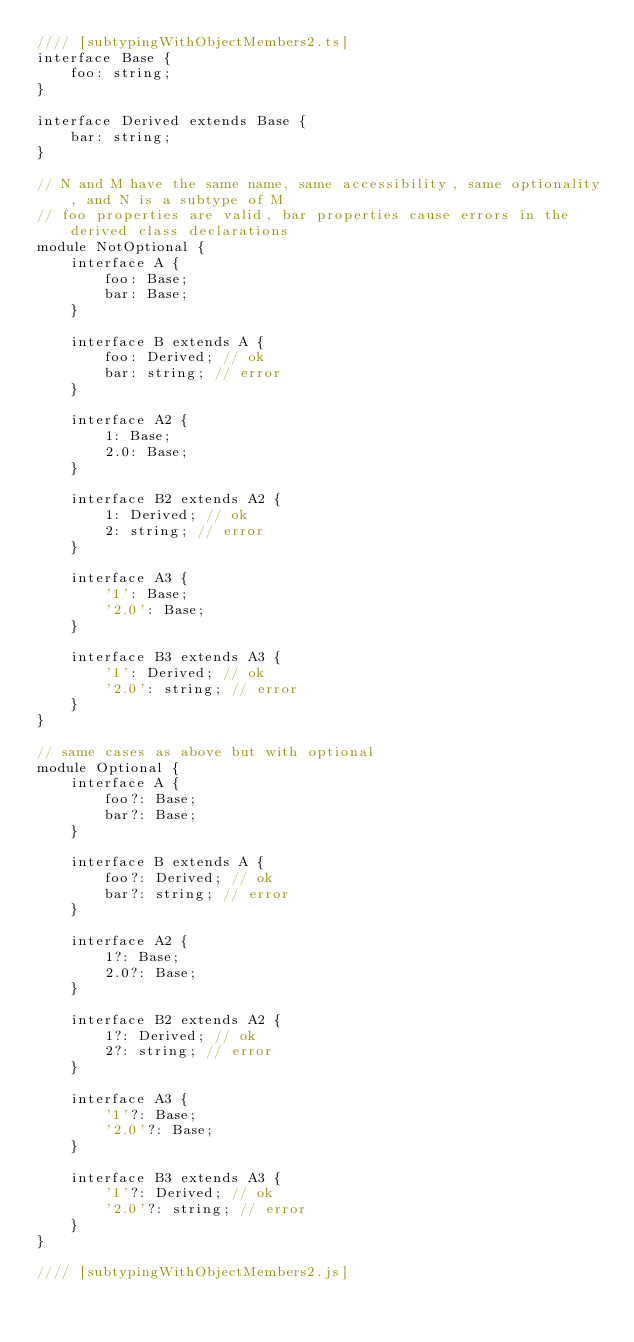<code> <loc_0><loc_0><loc_500><loc_500><_JavaScript_>//// [subtypingWithObjectMembers2.ts]
interface Base {
    foo: string;
}

interface Derived extends Base {
    bar: string;
}

// N and M have the same name, same accessibility, same optionality, and N is a subtype of M
// foo properties are valid, bar properties cause errors in the derived class declarations
module NotOptional {
    interface A {
        foo: Base;
        bar: Base;
    }

    interface B extends A {
        foo: Derived; // ok
        bar: string; // error
    }

    interface A2 {
        1: Base;
        2.0: Base;
    }

    interface B2 extends A2 {
        1: Derived; // ok
        2: string; // error
    }

    interface A3 {
        '1': Base;
        '2.0': Base;
    }

    interface B3 extends A3 {
        '1': Derived; // ok
        '2.0': string; // error
    }
}

// same cases as above but with optional
module Optional {
    interface A {
        foo?: Base;
        bar?: Base;
    }

    interface B extends A {
        foo?: Derived; // ok
        bar?: string; // error
    }

    interface A2 {
        1?: Base;
        2.0?: Base;
    }

    interface B2 extends A2 {
        1?: Derived; // ok
        2?: string; // error
    }

    interface A3 {
        '1'?: Base;
        '2.0'?: Base;
    }

    interface B3 extends A3 {
        '1'?: Derived; // ok
        '2.0'?: string; // error
    }
}

//// [subtypingWithObjectMembers2.js]
</code> 